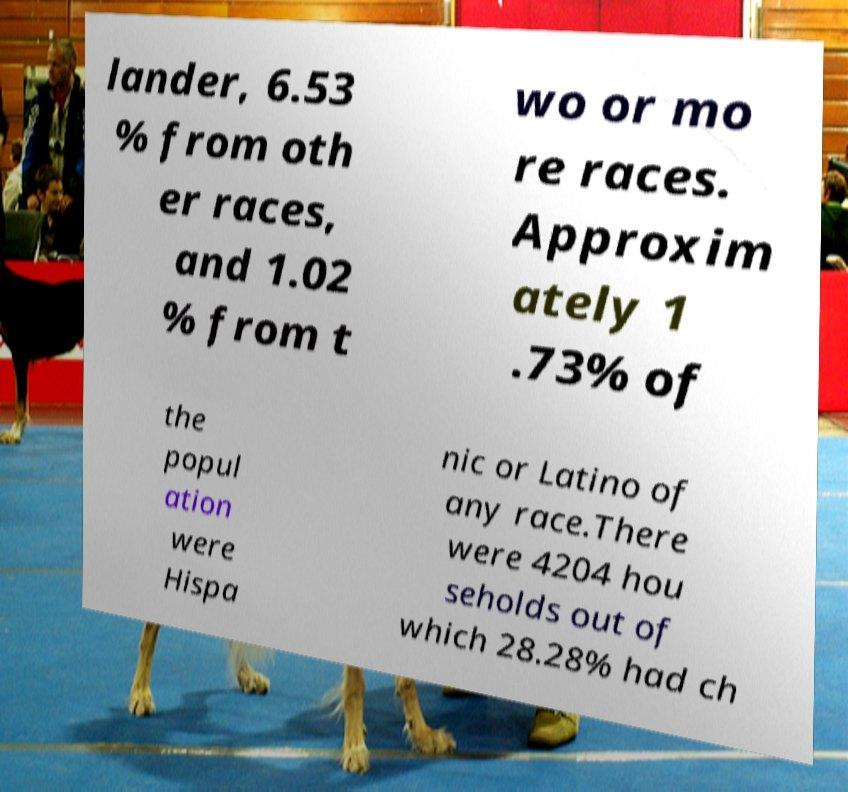There's text embedded in this image that I need extracted. Can you transcribe it verbatim? lander, 6.53 % from oth er races, and 1.02 % from t wo or mo re races. Approxim ately 1 .73% of the popul ation were Hispa nic or Latino of any race.There were 4204 hou seholds out of which 28.28% had ch 